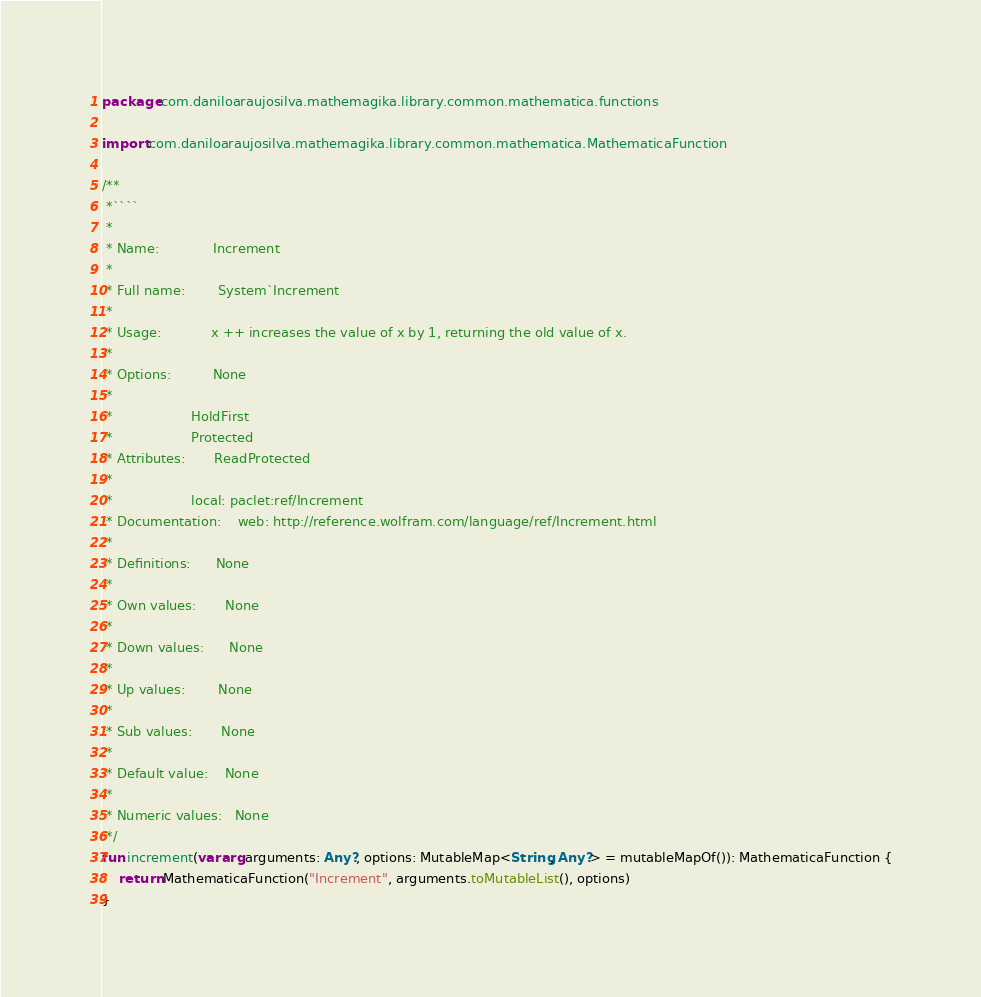<code> <loc_0><loc_0><loc_500><loc_500><_Kotlin_>package com.daniloaraujosilva.mathemagika.library.common.mathematica.functions

import com.daniloaraujosilva.mathemagika.library.common.mathematica.MathematicaFunction

/**
 *````
 *
 * Name:             Increment
 *
 * Full name:        System`Increment
 *
 * Usage:            x ++ increases the value of x by 1, returning the old value of x.
 *
 * Options:          None
 *
 *                   HoldFirst
 *                   Protected
 * Attributes:       ReadProtected
 *
 *                   local: paclet:ref/Increment
 * Documentation:    web: http://reference.wolfram.com/language/ref/Increment.html
 *
 * Definitions:      None
 *
 * Own values:       None
 *
 * Down values:      None
 *
 * Up values:        None
 *
 * Sub values:       None
 *
 * Default value:    None
 *
 * Numeric values:   None
 */
fun increment(vararg arguments: Any?, options: MutableMap<String, Any?> = mutableMapOf()): MathematicaFunction {
	return MathematicaFunction("Increment", arguments.toMutableList(), options)
}
</code> 